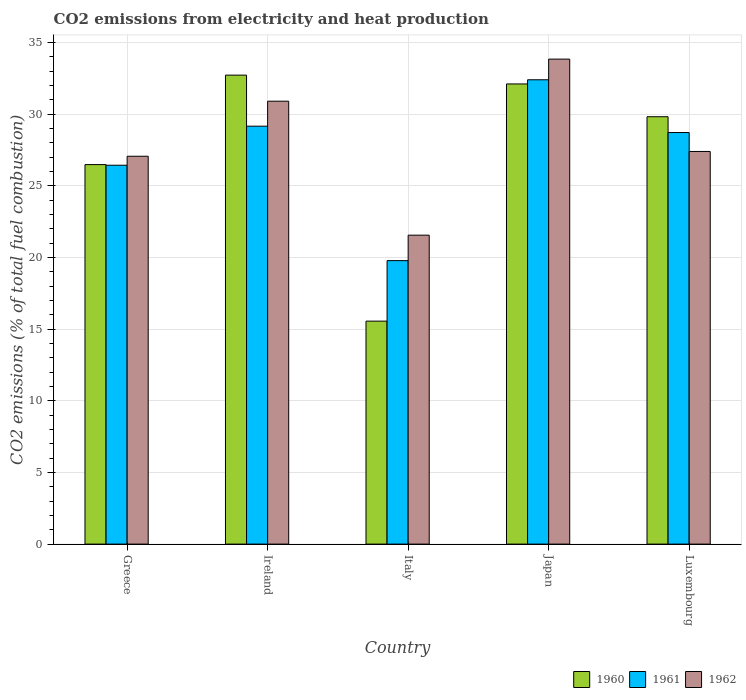How many different coloured bars are there?
Provide a short and direct response. 3. Are the number of bars per tick equal to the number of legend labels?
Ensure brevity in your answer.  Yes. Are the number of bars on each tick of the X-axis equal?
Your answer should be very brief. Yes. How many bars are there on the 2nd tick from the left?
Offer a very short reply. 3. How many bars are there on the 2nd tick from the right?
Your answer should be compact. 3. What is the label of the 2nd group of bars from the left?
Make the answer very short. Ireland. In how many cases, is the number of bars for a given country not equal to the number of legend labels?
Offer a very short reply. 0. What is the amount of CO2 emitted in 1960 in Luxembourg?
Your answer should be very brief. 29.81. Across all countries, what is the maximum amount of CO2 emitted in 1961?
Offer a terse response. 32.39. Across all countries, what is the minimum amount of CO2 emitted in 1960?
Give a very brief answer. 15.55. In which country was the amount of CO2 emitted in 1962 maximum?
Offer a very short reply. Japan. What is the total amount of CO2 emitted in 1961 in the graph?
Your response must be concise. 136.46. What is the difference between the amount of CO2 emitted in 1961 in Ireland and that in Japan?
Offer a very short reply. -3.24. What is the difference between the amount of CO2 emitted in 1961 in Ireland and the amount of CO2 emitted in 1962 in Japan?
Provide a short and direct response. -4.68. What is the average amount of CO2 emitted in 1961 per country?
Give a very brief answer. 27.29. What is the difference between the amount of CO2 emitted of/in 1962 and amount of CO2 emitted of/in 1960 in Italy?
Keep it short and to the point. 6. What is the ratio of the amount of CO2 emitted in 1961 in Greece to that in Japan?
Your answer should be very brief. 0.82. Is the amount of CO2 emitted in 1961 in Ireland less than that in Japan?
Give a very brief answer. Yes. What is the difference between the highest and the second highest amount of CO2 emitted in 1962?
Your response must be concise. 6.44. What is the difference between the highest and the lowest amount of CO2 emitted in 1961?
Your response must be concise. 12.62. What does the 1st bar from the right in Greece represents?
Ensure brevity in your answer.  1962. Are all the bars in the graph horizontal?
Offer a terse response. No. What is the difference between two consecutive major ticks on the Y-axis?
Keep it short and to the point. 5. Does the graph contain any zero values?
Provide a short and direct response. No. How many legend labels are there?
Provide a short and direct response. 3. What is the title of the graph?
Offer a terse response. CO2 emissions from electricity and heat production. What is the label or title of the Y-axis?
Ensure brevity in your answer.  CO2 emissions (% of total fuel combustion). What is the CO2 emissions (% of total fuel combustion) in 1960 in Greece?
Make the answer very short. 26.47. What is the CO2 emissions (% of total fuel combustion) of 1961 in Greece?
Offer a terse response. 26.43. What is the CO2 emissions (% of total fuel combustion) of 1962 in Greece?
Offer a terse response. 27.06. What is the CO2 emissions (% of total fuel combustion) in 1960 in Ireland?
Your answer should be compact. 32.72. What is the CO2 emissions (% of total fuel combustion) in 1961 in Ireland?
Provide a short and direct response. 29.15. What is the CO2 emissions (% of total fuel combustion) of 1962 in Ireland?
Your answer should be very brief. 30.9. What is the CO2 emissions (% of total fuel combustion) of 1960 in Italy?
Ensure brevity in your answer.  15.55. What is the CO2 emissions (% of total fuel combustion) in 1961 in Italy?
Make the answer very short. 19.78. What is the CO2 emissions (% of total fuel combustion) of 1962 in Italy?
Ensure brevity in your answer.  21.55. What is the CO2 emissions (% of total fuel combustion) in 1960 in Japan?
Offer a very short reply. 32.1. What is the CO2 emissions (% of total fuel combustion) of 1961 in Japan?
Provide a succinct answer. 32.39. What is the CO2 emissions (% of total fuel combustion) of 1962 in Japan?
Offer a terse response. 33.83. What is the CO2 emissions (% of total fuel combustion) of 1960 in Luxembourg?
Keep it short and to the point. 29.81. What is the CO2 emissions (% of total fuel combustion) of 1961 in Luxembourg?
Your answer should be very brief. 28.71. What is the CO2 emissions (% of total fuel combustion) in 1962 in Luxembourg?
Keep it short and to the point. 27.39. Across all countries, what is the maximum CO2 emissions (% of total fuel combustion) in 1960?
Make the answer very short. 32.72. Across all countries, what is the maximum CO2 emissions (% of total fuel combustion) of 1961?
Offer a very short reply. 32.39. Across all countries, what is the maximum CO2 emissions (% of total fuel combustion) in 1962?
Your answer should be very brief. 33.83. Across all countries, what is the minimum CO2 emissions (% of total fuel combustion) of 1960?
Offer a very short reply. 15.55. Across all countries, what is the minimum CO2 emissions (% of total fuel combustion) of 1961?
Your response must be concise. 19.78. Across all countries, what is the minimum CO2 emissions (% of total fuel combustion) in 1962?
Keep it short and to the point. 21.55. What is the total CO2 emissions (% of total fuel combustion) of 1960 in the graph?
Provide a succinct answer. 136.66. What is the total CO2 emissions (% of total fuel combustion) in 1961 in the graph?
Your answer should be very brief. 136.46. What is the total CO2 emissions (% of total fuel combustion) in 1962 in the graph?
Provide a succinct answer. 140.73. What is the difference between the CO2 emissions (% of total fuel combustion) in 1960 in Greece and that in Ireland?
Make the answer very short. -6.24. What is the difference between the CO2 emissions (% of total fuel combustion) of 1961 in Greece and that in Ireland?
Ensure brevity in your answer.  -2.72. What is the difference between the CO2 emissions (% of total fuel combustion) in 1962 in Greece and that in Ireland?
Provide a succinct answer. -3.84. What is the difference between the CO2 emissions (% of total fuel combustion) in 1960 in Greece and that in Italy?
Provide a short and direct response. 10.92. What is the difference between the CO2 emissions (% of total fuel combustion) of 1961 in Greece and that in Italy?
Ensure brevity in your answer.  6.66. What is the difference between the CO2 emissions (% of total fuel combustion) of 1962 in Greece and that in Italy?
Offer a very short reply. 5.51. What is the difference between the CO2 emissions (% of total fuel combustion) in 1960 in Greece and that in Japan?
Offer a terse response. -5.63. What is the difference between the CO2 emissions (% of total fuel combustion) of 1961 in Greece and that in Japan?
Keep it short and to the point. -5.96. What is the difference between the CO2 emissions (% of total fuel combustion) in 1962 in Greece and that in Japan?
Ensure brevity in your answer.  -6.78. What is the difference between the CO2 emissions (% of total fuel combustion) of 1960 in Greece and that in Luxembourg?
Ensure brevity in your answer.  -3.34. What is the difference between the CO2 emissions (% of total fuel combustion) of 1961 in Greece and that in Luxembourg?
Give a very brief answer. -2.28. What is the difference between the CO2 emissions (% of total fuel combustion) of 1962 in Greece and that in Luxembourg?
Your response must be concise. -0.33. What is the difference between the CO2 emissions (% of total fuel combustion) of 1960 in Ireland and that in Italy?
Ensure brevity in your answer.  17.16. What is the difference between the CO2 emissions (% of total fuel combustion) of 1961 in Ireland and that in Italy?
Ensure brevity in your answer.  9.38. What is the difference between the CO2 emissions (% of total fuel combustion) of 1962 in Ireland and that in Italy?
Offer a very short reply. 9.35. What is the difference between the CO2 emissions (% of total fuel combustion) in 1960 in Ireland and that in Japan?
Give a very brief answer. 0.61. What is the difference between the CO2 emissions (% of total fuel combustion) of 1961 in Ireland and that in Japan?
Provide a short and direct response. -3.24. What is the difference between the CO2 emissions (% of total fuel combustion) of 1962 in Ireland and that in Japan?
Your answer should be very brief. -2.94. What is the difference between the CO2 emissions (% of total fuel combustion) of 1960 in Ireland and that in Luxembourg?
Keep it short and to the point. 2.9. What is the difference between the CO2 emissions (% of total fuel combustion) in 1961 in Ireland and that in Luxembourg?
Offer a very short reply. 0.44. What is the difference between the CO2 emissions (% of total fuel combustion) of 1962 in Ireland and that in Luxembourg?
Offer a terse response. 3.51. What is the difference between the CO2 emissions (% of total fuel combustion) of 1960 in Italy and that in Japan?
Your answer should be very brief. -16.55. What is the difference between the CO2 emissions (% of total fuel combustion) of 1961 in Italy and that in Japan?
Provide a short and direct response. -12.62. What is the difference between the CO2 emissions (% of total fuel combustion) in 1962 in Italy and that in Japan?
Provide a succinct answer. -12.28. What is the difference between the CO2 emissions (% of total fuel combustion) of 1960 in Italy and that in Luxembourg?
Offer a terse response. -14.26. What is the difference between the CO2 emissions (% of total fuel combustion) of 1961 in Italy and that in Luxembourg?
Ensure brevity in your answer.  -8.93. What is the difference between the CO2 emissions (% of total fuel combustion) in 1962 in Italy and that in Luxembourg?
Your response must be concise. -5.84. What is the difference between the CO2 emissions (% of total fuel combustion) of 1960 in Japan and that in Luxembourg?
Your answer should be compact. 2.29. What is the difference between the CO2 emissions (% of total fuel combustion) of 1961 in Japan and that in Luxembourg?
Provide a short and direct response. 3.68. What is the difference between the CO2 emissions (% of total fuel combustion) of 1962 in Japan and that in Luxembourg?
Your answer should be compact. 6.44. What is the difference between the CO2 emissions (% of total fuel combustion) of 1960 in Greece and the CO2 emissions (% of total fuel combustion) of 1961 in Ireland?
Your answer should be compact. -2.68. What is the difference between the CO2 emissions (% of total fuel combustion) of 1960 in Greece and the CO2 emissions (% of total fuel combustion) of 1962 in Ireland?
Your response must be concise. -4.42. What is the difference between the CO2 emissions (% of total fuel combustion) of 1961 in Greece and the CO2 emissions (% of total fuel combustion) of 1962 in Ireland?
Your answer should be very brief. -4.47. What is the difference between the CO2 emissions (% of total fuel combustion) in 1960 in Greece and the CO2 emissions (% of total fuel combustion) in 1961 in Italy?
Your response must be concise. 6.7. What is the difference between the CO2 emissions (% of total fuel combustion) of 1960 in Greece and the CO2 emissions (% of total fuel combustion) of 1962 in Italy?
Make the answer very short. 4.92. What is the difference between the CO2 emissions (% of total fuel combustion) of 1961 in Greece and the CO2 emissions (% of total fuel combustion) of 1962 in Italy?
Ensure brevity in your answer.  4.88. What is the difference between the CO2 emissions (% of total fuel combustion) of 1960 in Greece and the CO2 emissions (% of total fuel combustion) of 1961 in Japan?
Make the answer very short. -5.92. What is the difference between the CO2 emissions (% of total fuel combustion) of 1960 in Greece and the CO2 emissions (% of total fuel combustion) of 1962 in Japan?
Provide a short and direct response. -7.36. What is the difference between the CO2 emissions (% of total fuel combustion) of 1961 in Greece and the CO2 emissions (% of total fuel combustion) of 1962 in Japan?
Provide a succinct answer. -7.4. What is the difference between the CO2 emissions (% of total fuel combustion) of 1960 in Greece and the CO2 emissions (% of total fuel combustion) of 1961 in Luxembourg?
Keep it short and to the point. -2.24. What is the difference between the CO2 emissions (% of total fuel combustion) in 1960 in Greece and the CO2 emissions (% of total fuel combustion) in 1962 in Luxembourg?
Your answer should be compact. -0.92. What is the difference between the CO2 emissions (% of total fuel combustion) of 1961 in Greece and the CO2 emissions (% of total fuel combustion) of 1962 in Luxembourg?
Offer a very short reply. -0.96. What is the difference between the CO2 emissions (% of total fuel combustion) of 1960 in Ireland and the CO2 emissions (% of total fuel combustion) of 1961 in Italy?
Ensure brevity in your answer.  12.94. What is the difference between the CO2 emissions (% of total fuel combustion) of 1960 in Ireland and the CO2 emissions (% of total fuel combustion) of 1962 in Italy?
Keep it short and to the point. 11.16. What is the difference between the CO2 emissions (% of total fuel combustion) in 1961 in Ireland and the CO2 emissions (% of total fuel combustion) in 1962 in Italy?
Give a very brief answer. 7.6. What is the difference between the CO2 emissions (% of total fuel combustion) in 1960 in Ireland and the CO2 emissions (% of total fuel combustion) in 1961 in Japan?
Ensure brevity in your answer.  0.32. What is the difference between the CO2 emissions (% of total fuel combustion) of 1960 in Ireland and the CO2 emissions (% of total fuel combustion) of 1962 in Japan?
Your answer should be compact. -1.12. What is the difference between the CO2 emissions (% of total fuel combustion) of 1961 in Ireland and the CO2 emissions (% of total fuel combustion) of 1962 in Japan?
Your response must be concise. -4.68. What is the difference between the CO2 emissions (% of total fuel combustion) in 1960 in Ireland and the CO2 emissions (% of total fuel combustion) in 1961 in Luxembourg?
Ensure brevity in your answer.  4.01. What is the difference between the CO2 emissions (% of total fuel combustion) in 1960 in Ireland and the CO2 emissions (% of total fuel combustion) in 1962 in Luxembourg?
Make the answer very short. 5.33. What is the difference between the CO2 emissions (% of total fuel combustion) in 1961 in Ireland and the CO2 emissions (% of total fuel combustion) in 1962 in Luxembourg?
Your answer should be compact. 1.76. What is the difference between the CO2 emissions (% of total fuel combustion) in 1960 in Italy and the CO2 emissions (% of total fuel combustion) in 1961 in Japan?
Give a very brief answer. -16.84. What is the difference between the CO2 emissions (% of total fuel combustion) of 1960 in Italy and the CO2 emissions (% of total fuel combustion) of 1962 in Japan?
Offer a terse response. -18.28. What is the difference between the CO2 emissions (% of total fuel combustion) in 1961 in Italy and the CO2 emissions (% of total fuel combustion) in 1962 in Japan?
Provide a succinct answer. -14.06. What is the difference between the CO2 emissions (% of total fuel combustion) in 1960 in Italy and the CO2 emissions (% of total fuel combustion) in 1961 in Luxembourg?
Provide a succinct answer. -13.16. What is the difference between the CO2 emissions (% of total fuel combustion) of 1960 in Italy and the CO2 emissions (% of total fuel combustion) of 1962 in Luxembourg?
Give a very brief answer. -11.84. What is the difference between the CO2 emissions (% of total fuel combustion) in 1961 in Italy and the CO2 emissions (% of total fuel combustion) in 1962 in Luxembourg?
Ensure brevity in your answer.  -7.62. What is the difference between the CO2 emissions (% of total fuel combustion) in 1960 in Japan and the CO2 emissions (% of total fuel combustion) in 1961 in Luxembourg?
Your response must be concise. 3.39. What is the difference between the CO2 emissions (% of total fuel combustion) of 1960 in Japan and the CO2 emissions (% of total fuel combustion) of 1962 in Luxembourg?
Make the answer very short. 4.71. What is the difference between the CO2 emissions (% of total fuel combustion) of 1961 in Japan and the CO2 emissions (% of total fuel combustion) of 1962 in Luxembourg?
Keep it short and to the point. 5. What is the average CO2 emissions (% of total fuel combustion) of 1960 per country?
Your answer should be compact. 27.33. What is the average CO2 emissions (% of total fuel combustion) of 1961 per country?
Ensure brevity in your answer.  27.29. What is the average CO2 emissions (% of total fuel combustion) of 1962 per country?
Provide a short and direct response. 28.15. What is the difference between the CO2 emissions (% of total fuel combustion) of 1960 and CO2 emissions (% of total fuel combustion) of 1961 in Greece?
Offer a terse response. 0.04. What is the difference between the CO2 emissions (% of total fuel combustion) of 1960 and CO2 emissions (% of total fuel combustion) of 1962 in Greece?
Make the answer very short. -0.58. What is the difference between the CO2 emissions (% of total fuel combustion) in 1961 and CO2 emissions (% of total fuel combustion) in 1962 in Greece?
Ensure brevity in your answer.  -0.63. What is the difference between the CO2 emissions (% of total fuel combustion) of 1960 and CO2 emissions (% of total fuel combustion) of 1961 in Ireland?
Keep it short and to the point. 3.56. What is the difference between the CO2 emissions (% of total fuel combustion) of 1960 and CO2 emissions (% of total fuel combustion) of 1962 in Ireland?
Keep it short and to the point. 1.82. What is the difference between the CO2 emissions (% of total fuel combustion) of 1961 and CO2 emissions (% of total fuel combustion) of 1962 in Ireland?
Keep it short and to the point. -1.74. What is the difference between the CO2 emissions (% of total fuel combustion) in 1960 and CO2 emissions (% of total fuel combustion) in 1961 in Italy?
Make the answer very short. -4.22. What is the difference between the CO2 emissions (% of total fuel combustion) in 1960 and CO2 emissions (% of total fuel combustion) in 1962 in Italy?
Ensure brevity in your answer.  -6. What is the difference between the CO2 emissions (% of total fuel combustion) in 1961 and CO2 emissions (% of total fuel combustion) in 1962 in Italy?
Keep it short and to the point. -1.78. What is the difference between the CO2 emissions (% of total fuel combustion) of 1960 and CO2 emissions (% of total fuel combustion) of 1961 in Japan?
Your answer should be very brief. -0.29. What is the difference between the CO2 emissions (% of total fuel combustion) of 1960 and CO2 emissions (% of total fuel combustion) of 1962 in Japan?
Give a very brief answer. -1.73. What is the difference between the CO2 emissions (% of total fuel combustion) in 1961 and CO2 emissions (% of total fuel combustion) in 1962 in Japan?
Your response must be concise. -1.44. What is the difference between the CO2 emissions (% of total fuel combustion) in 1960 and CO2 emissions (% of total fuel combustion) in 1961 in Luxembourg?
Keep it short and to the point. 1.1. What is the difference between the CO2 emissions (% of total fuel combustion) of 1960 and CO2 emissions (% of total fuel combustion) of 1962 in Luxembourg?
Your response must be concise. 2.42. What is the difference between the CO2 emissions (% of total fuel combustion) of 1961 and CO2 emissions (% of total fuel combustion) of 1962 in Luxembourg?
Give a very brief answer. 1.32. What is the ratio of the CO2 emissions (% of total fuel combustion) in 1960 in Greece to that in Ireland?
Your response must be concise. 0.81. What is the ratio of the CO2 emissions (% of total fuel combustion) in 1961 in Greece to that in Ireland?
Ensure brevity in your answer.  0.91. What is the ratio of the CO2 emissions (% of total fuel combustion) of 1962 in Greece to that in Ireland?
Ensure brevity in your answer.  0.88. What is the ratio of the CO2 emissions (% of total fuel combustion) of 1960 in Greece to that in Italy?
Offer a very short reply. 1.7. What is the ratio of the CO2 emissions (% of total fuel combustion) in 1961 in Greece to that in Italy?
Keep it short and to the point. 1.34. What is the ratio of the CO2 emissions (% of total fuel combustion) in 1962 in Greece to that in Italy?
Provide a short and direct response. 1.26. What is the ratio of the CO2 emissions (% of total fuel combustion) in 1960 in Greece to that in Japan?
Give a very brief answer. 0.82. What is the ratio of the CO2 emissions (% of total fuel combustion) in 1961 in Greece to that in Japan?
Offer a terse response. 0.82. What is the ratio of the CO2 emissions (% of total fuel combustion) in 1962 in Greece to that in Japan?
Offer a very short reply. 0.8. What is the ratio of the CO2 emissions (% of total fuel combustion) of 1960 in Greece to that in Luxembourg?
Offer a very short reply. 0.89. What is the ratio of the CO2 emissions (% of total fuel combustion) in 1961 in Greece to that in Luxembourg?
Your response must be concise. 0.92. What is the ratio of the CO2 emissions (% of total fuel combustion) in 1960 in Ireland to that in Italy?
Ensure brevity in your answer.  2.1. What is the ratio of the CO2 emissions (% of total fuel combustion) of 1961 in Ireland to that in Italy?
Provide a succinct answer. 1.47. What is the ratio of the CO2 emissions (% of total fuel combustion) in 1962 in Ireland to that in Italy?
Your answer should be very brief. 1.43. What is the ratio of the CO2 emissions (% of total fuel combustion) of 1960 in Ireland to that in Japan?
Offer a very short reply. 1.02. What is the ratio of the CO2 emissions (% of total fuel combustion) in 1962 in Ireland to that in Japan?
Offer a very short reply. 0.91. What is the ratio of the CO2 emissions (% of total fuel combustion) of 1960 in Ireland to that in Luxembourg?
Make the answer very short. 1.1. What is the ratio of the CO2 emissions (% of total fuel combustion) in 1961 in Ireland to that in Luxembourg?
Keep it short and to the point. 1.02. What is the ratio of the CO2 emissions (% of total fuel combustion) of 1962 in Ireland to that in Luxembourg?
Your answer should be compact. 1.13. What is the ratio of the CO2 emissions (% of total fuel combustion) of 1960 in Italy to that in Japan?
Ensure brevity in your answer.  0.48. What is the ratio of the CO2 emissions (% of total fuel combustion) of 1961 in Italy to that in Japan?
Make the answer very short. 0.61. What is the ratio of the CO2 emissions (% of total fuel combustion) of 1962 in Italy to that in Japan?
Your answer should be compact. 0.64. What is the ratio of the CO2 emissions (% of total fuel combustion) in 1960 in Italy to that in Luxembourg?
Offer a terse response. 0.52. What is the ratio of the CO2 emissions (% of total fuel combustion) in 1961 in Italy to that in Luxembourg?
Provide a short and direct response. 0.69. What is the ratio of the CO2 emissions (% of total fuel combustion) in 1962 in Italy to that in Luxembourg?
Make the answer very short. 0.79. What is the ratio of the CO2 emissions (% of total fuel combustion) of 1960 in Japan to that in Luxembourg?
Provide a succinct answer. 1.08. What is the ratio of the CO2 emissions (% of total fuel combustion) of 1961 in Japan to that in Luxembourg?
Your answer should be very brief. 1.13. What is the ratio of the CO2 emissions (% of total fuel combustion) of 1962 in Japan to that in Luxembourg?
Your answer should be very brief. 1.24. What is the difference between the highest and the second highest CO2 emissions (% of total fuel combustion) in 1960?
Keep it short and to the point. 0.61. What is the difference between the highest and the second highest CO2 emissions (% of total fuel combustion) of 1961?
Keep it short and to the point. 3.24. What is the difference between the highest and the second highest CO2 emissions (% of total fuel combustion) in 1962?
Your answer should be very brief. 2.94. What is the difference between the highest and the lowest CO2 emissions (% of total fuel combustion) of 1960?
Make the answer very short. 17.16. What is the difference between the highest and the lowest CO2 emissions (% of total fuel combustion) in 1961?
Ensure brevity in your answer.  12.62. What is the difference between the highest and the lowest CO2 emissions (% of total fuel combustion) in 1962?
Your answer should be very brief. 12.28. 